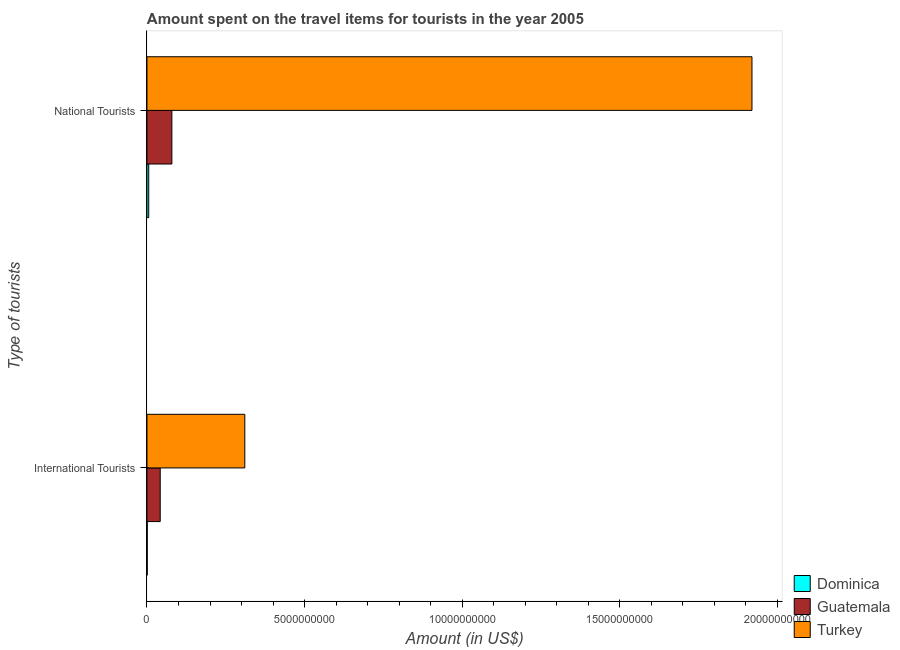How many groups of bars are there?
Your answer should be compact. 2. What is the label of the 1st group of bars from the top?
Make the answer very short. National Tourists. What is the amount spent on travel items of international tourists in Turkey?
Your answer should be very brief. 3.10e+09. Across all countries, what is the maximum amount spent on travel items of national tourists?
Make the answer very short. 1.92e+1. Across all countries, what is the minimum amount spent on travel items of international tourists?
Your response must be concise. 1.00e+07. In which country was the amount spent on travel items of national tourists minimum?
Provide a short and direct response. Dominica. What is the total amount spent on travel items of international tourists in the graph?
Provide a succinct answer. 3.54e+09. What is the difference between the amount spent on travel items of national tourists in Turkey and that in Guatemala?
Keep it short and to the point. 1.84e+1. What is the difference between the amount spent on travel items of national tourists in Guatemala and the amount spent on travel items of international tourists in Turkey?
Your answer should be compact. -2.31e+09. What is the average amount spent on travel items of national tourists per country?
Give a very brief answer. 6.68e+09. What is the difference between the amount spent on travel items of national tourists and amount spent on travel items of international tourists in Guatemala?
Ensure brevity in your answer.  3.70e+08. In how many countries, is the amount spent on travel items of international tourists greater than 15000000000 US$?
Provide a short and direct response. 0. What is the ratio of the amount spent on travel items of international tourists in Guatemala to that in Turkey?
Your answer should be compact. 0.14. Is the amount spent on travel items of international tourists in Guatemala less than that in Dominica?
Make the answer very short. No. What does the 3rd bar from the top in International Tourists represents?
Offer a very short reply. Dominica. What does the 3rd bar from the bottom in International Tourists represents?
Provide a short and direct response. Turkey. Are all the bars in the graph horizontal?
Give a very brief answer. Yes. How many countries are there in the graph?
Offer a very short reply. 3. Are the values on the major ticks of X-axis written in scientific E-notation?
Offer a very short reply. No. Does the graph contain grids?
Your answer should be very brief. No. Where does the legend appear in the graph?
Make the answer very short. Bottom right. What is the title of the graph?
Provide a succinct answer. Amount spent on the travel items for tourists in the year 2005. Does "Canada" appear as one of the legend labels in the graph?
Your answer should be compact. No. What is the label or title of the X-axis?
Your response must be concise. Amount (in US$). What is the label or title of the Y-axis?
Your response must be concise. Type of tourists. What is the Amount (in US$) of Guatemala in International Tourists?
Your answer should be compact. 4.21e+08. What is the Amount (in US$) in Turkey in International Tourists?
Your response must be concise. 3.10e+09. What is the Amount (in US$) in Dominica in National Tourists?
Ensure brevity in your answer.  5.70e+07. What is the Amount (in US$) of Guatemala in National Tourists?
Ensure brevity in your answer.  7.91e+08. What is the Amount (in US$) of Turkey in National Tourists?
Keep it short and to the point. 1.92e+1. Across all Type of tourists, what is the maximum Amount (in US$) in Dominica?
Your answer should be very brief. 5.70e+07. Across all Type of tourists, what is the maximum Amount (in US$) of Guatemala?
Keep it short and to the point. 7.91e+08. Across all Type of tourists, what is the maximum Amount (in US$) in Turkey?
Your response must be concise. 1.92e+1. Across all Type of tourists, what is the minimum Amount (in US$) of Dominica?
Provide a succinct answer. 1.00e+07. Across all Type of tourists, what is the minimum Amount (in US$) in Guatemala?
Your answer should be very brief. 4.21e+08. Across all Type of tourists, what is the minimum Amount (in US$) in Turkey?
Provide a short and direct response. 3.10e+09. What is the total Amount (in US$) of Dominica in the graph?
Keep it short and to the point. 6.70e+07. What is the total Amount (in US$) of Guatemala in the graph?
Offer a very short reply. 1.21e+09. What is the total Amount (in US$) in Turkey in the graph?
Make the answer very short. 2.23e+1. What is the difference between the Amount (in US$) in Dominica in International Tourists and that in National Tourists?
Your answer should be very brief. -4.70e+07. What is the difference between the Amount (in US$) of Guatemala in International Tourists and that in National Tourists?
Make the answer very short. -3.70e+08. What is the difference between the Amount (in US$) of Turkey in International Tourists and that in National Tourists?
Make the answer very short. -1.61e+1. What is the difference between the Amount (in US$) of Dominica in International Tourists and the Amount (in US$) of Guatemala in National Tourists?
Your answer should be very brief. -7.81e+08. What is the difference between the Amount (in US$) of Dominica in International Tourists and the Amount (in US$) of Turkey in National Tourists?
Ensure brevity in your answer.  -1.92e+1. What is the difference between the Amount (in US$) in Guatemala in International Tourists and the Amount (in US$) in Turkey in National Tourists?
Provide a succinct answer. -1.88e+1. What is the average Amount (in US$) in Dominica per Type of tourists?
Offer a terse response. 3.35e+07. What is the average Amount (in US$) in Guatemala per Type of tourists?
Make the answer very short. 6.06e+08. What is the average Amount (in US$) in Turkey per Type of tourists?
Your response must be concise. 1.11e+1. What is the difference between the Amount (in US$) in Dominica and Amount (in US$) in Guatemala in International Tourists?
Provide a short and direct response. -4.11e+08. What is the difference between the Amount (in US$) in Dominica and Amount (in US$) in Turkey in International Tourists?
Provide a short and direct response. -3.09e+09. What is the difference between the Amount (in US$) of Guatemala and Amount (in US$) of Turkey in International Tourists?
Offer a very short reply. -2.68e+09. What is the difference between the Amount (in US$) of Dominica and Amount (in US$) of Guatemala in National Tourists?
Your response must be concise. -7.34e+08. What is the difference between the Amount (in US$) of Dominica and Amount (in US$) of Turkey in National Tourists?
Make the answer very short. -1.91e+1. What is the difference between the Amount (in US$) of Guatemala and Amount (in US$) of Turkey in National Tourists?
Offer a terse response. -1.84e+1. What is the ratio of the Amount (in US$) of Dominica in International Tourists to that in National Tourists?
Give a very brief answer. 0.18. What is the ratio of the Amount (in US$) of Guatemala in International Tourists to that in National Tourists?
Make the answer very short. 0.53. What is the ratio of the Amount (in US$) of Turkey in International Tourists to that in National Tourists?
Give a very brief answer. 0.16. What is the difference between the highest and the second highest Amount (in US$) of Dominica?
Your response must be concise. 4.70e+07. What is the difference between the highest and the second highest Amount (in US$) of Guatemala?
Your answer should be compact. 3.70e+08. What is the difference between the highest and the second highest Amount (in US$) in Turkey?
Your answer should be compact. 1.61e+1. What is the difference between the highest and the lowest Amount (in US$) in Dominica?
Your answer should be very brief. 4.70e+07. What is the difference between the highest and the lowest Amount (in US$) in Guatemala?
Keep it short and to the point. 3.70e+08. What is the difference between the highest and the lowest Amount (in US$) in Turkey?
Offer a very short reply. 1.61e+1. 